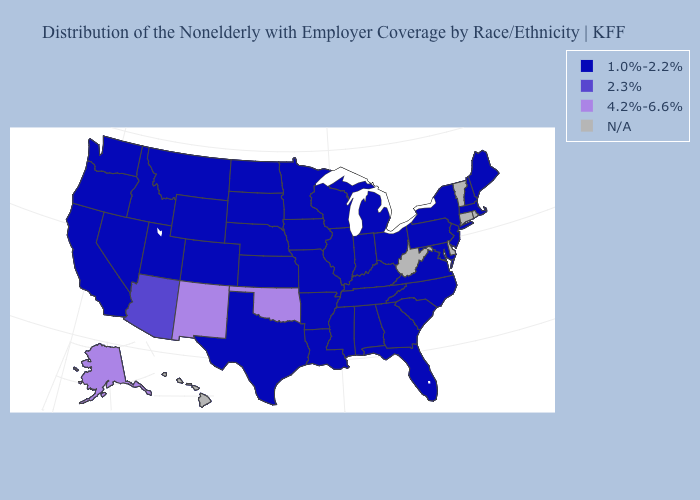What is the value of Montana?
Give a very brief answer. 1.0%-2.2%. Which states have the lowest value in the USA?
Be succinct. Alabama, Arkansas, California, Colorado, Florida, Georgia, Idaho, Illinois, Indiana, Iowa, Kansas, Kentucky, Louisiana, Maine, Maryland, Massachusetts, Michigan, Minnesota, Mississippi, Missouri, Montana, Nebraska, Nevada, New Hampshire, New Jersey, New York, North Carolina, North Dakota, Ohio, Oregon, Pennsylvania, South Carolina, South Dakota, Tennessee, Texas, Utah, Virginia, Washington, Wisconsin, Wyoming. What is the highest value in states that border California?
Concise answer only. 2.3%. Does the map have missing data?
Write a very short answer. Yes. What is the lowest value in the South?
Write a very short answer. 1.0%-2.2%. What is the value of Iowa?
Quick response, please. 1.0%-2.2%. What is the highest value in states that border Rhode Island?
Keep it brief. 1.0%-2.2%. What is the lowest value in states that border Delaware?
Be succinct. 1.0%-2.2%. Which states have the lowest value in the MidWest?
Give a very brief answer. Illinois, Indiana, Iowa, Kansas, Michigan, Minnesota, Missouri, Nebraska, North Dakota, Ohio, South Dakota, Wisconsin. Does the first symbol in the legend represent the smallest category?
Concise answer only. Yes. Which states have the lowest value in the USA?
Write a very short answer. Alabama, Arkansas, California, Colorado, Florida, Georgia, Idaho, Illinois, Indiana, Iowa, Kansas, Kentucky, Louisiana, Maine, Maryland, Massachusetts, Michigan, Minnesota, Mississippi, Missouri, Montana, Nebraska, Nevada, New Hampshire, New Jersey, New York, North Carolina, North Dakota, Ohio, Oregon, Pennsylvania, South Carolina, South Dakota, Tennessee, Texas, Utah, Virginia, Washington, Wisconsin, Wyoming. Does the first symbol in the legend represent the smallest category?
Write a very short answer. Yes. Which states have the lowest value in the South?
Concise answer only. Alabama, Arkansas, Florida, Georgia, Kentucky, Louisiana, Maryland, Mississippi, North Carolina, South Carolina, Tennessee, Texas, Virginia. What is the lowest value in the MidWest?
Give a very brief answer. 1.0%-2.2%. Name the states that have a value in the range 2.3%?
Answer briefly. Arizona. 